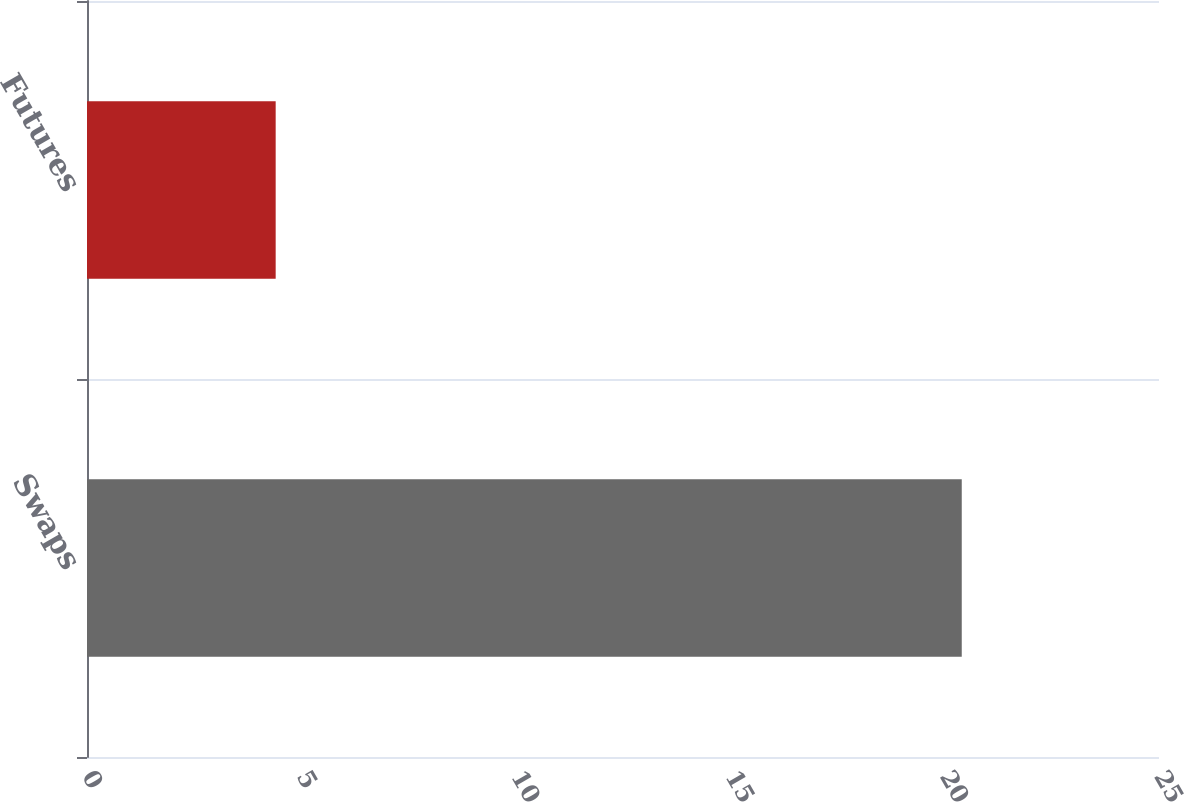Convert chart to OTSL. <chart><loc_0><loc_0><loc_500><loc_500><bar_chart><fcel>Swaps<fcel>Futures<nl><fcel>20.4<fcel>4.4<nl></chart> 